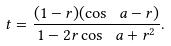<formula> <loc_0><loc_0><loc_500><loc_500>\ t = \frac { ( 1 - r ) ( \cos \ a - r ) } { 1 - 2 r \cos \ a + r ^ { 2 } } .</formula> 